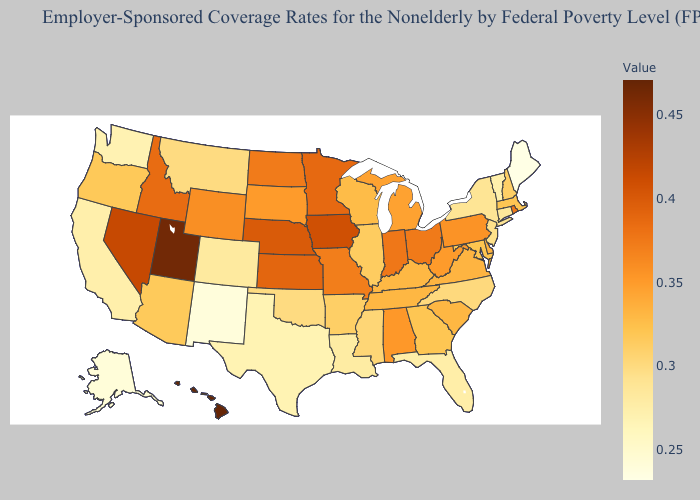Which states have the lowest value in the USA?
Quick response, please. Maine. Which states have the lowest value in the West?
Short answer required. New Mexico. Does Alabama have the highest value in the South?
Be succinct. Yes. Is the legend a continuous bar?
Keep it brief. Yes. 